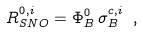<formula> <loc_0><loc_0><loc_500><loc_500>R _ { S N O } ^ { 0 , i } = \Phi _ { B } ^ { 0 } \, \sigma _ { B } ^ { c , i } \ ,</formula> 